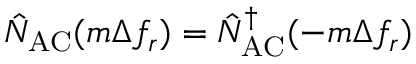<formula> <loc_0><loc_0><loc_500><loc_500>\hat { N } _ { A C } ( m \Delta f _ { r } ) = \hat { N } _ { A C } ^ { \dagger } ( - m \Delta f _ { r } )</formula> 